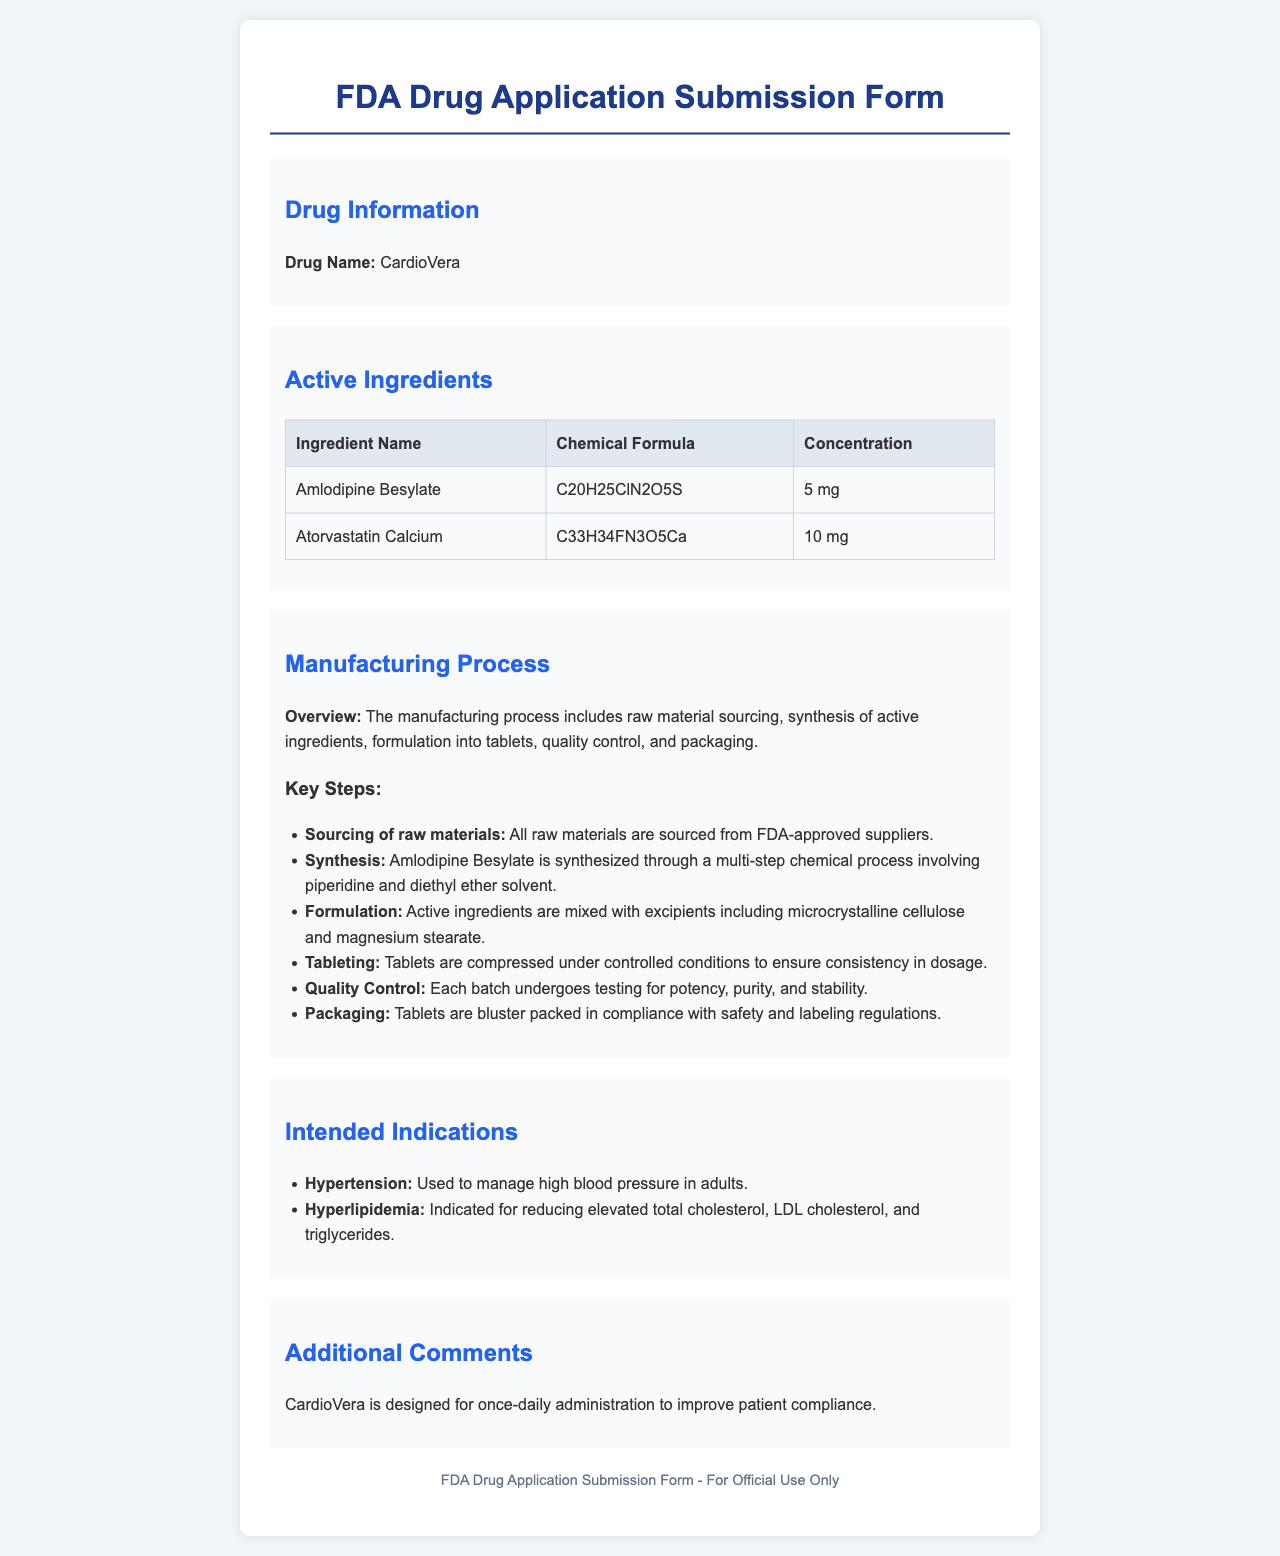What is the drug name? The drug name is located in the Drug Information section of the document.
Answer: CardioVera What is the concentration of Amlodipine Besylate? The concentration of Amlodipine Besylate is stated in the Active Ingredients section.
Answer: 5 mg How many active ingredients are listed? The number of active ingredients can be counted from the Active Ingredients table.
Answer: 2 What is the first key step in the manufacturing process? The first key step is detailed in the Key Steps subsection of the Manufacturing Process section.
Answer: Sourcing of raw materials What is CardioVera indicated for? The intended indications are listed in a bulleted format, highlighting all uses of the drug.
Answer: Hypertension How is Amlodipine Besylate synthesized? The synthesis method is explained in the Key Steps of the Manufacturing Process section.
Answer: Multi-step chemical process What is the last item in the Quality Control steps? The last item is provided in the Key Steps of the Manufacturing Process section.
Answer: Testing for potency, purity, and stability What is the packaging compliance for CardioVera? This information is found in the Packaging step of the Manufacturing Process section.
Answer: Safety and labeling regulations What is the recommended administration frequency for CardioVera? The administration frequency is mentioned in the Additional Comments section.
Answer: Once-daily 